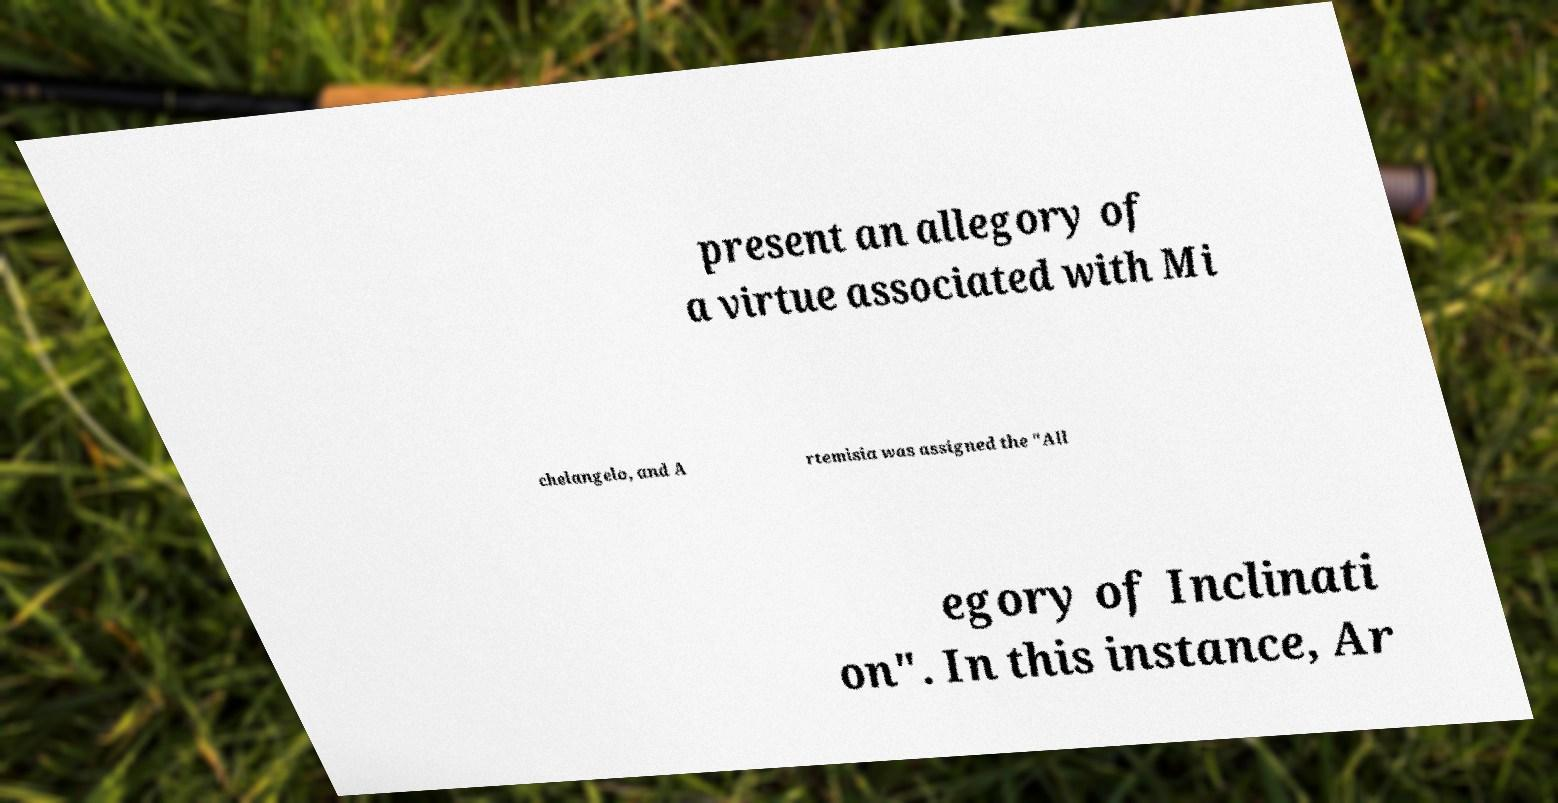There's text embedded in this image that I need extracted. Can you transcribe it verbatim? present an allegory of a virtue associated with Mi chelangelo, and A rtemisia was assigned the "All egory of Inclinati on". In this instance, Ar 